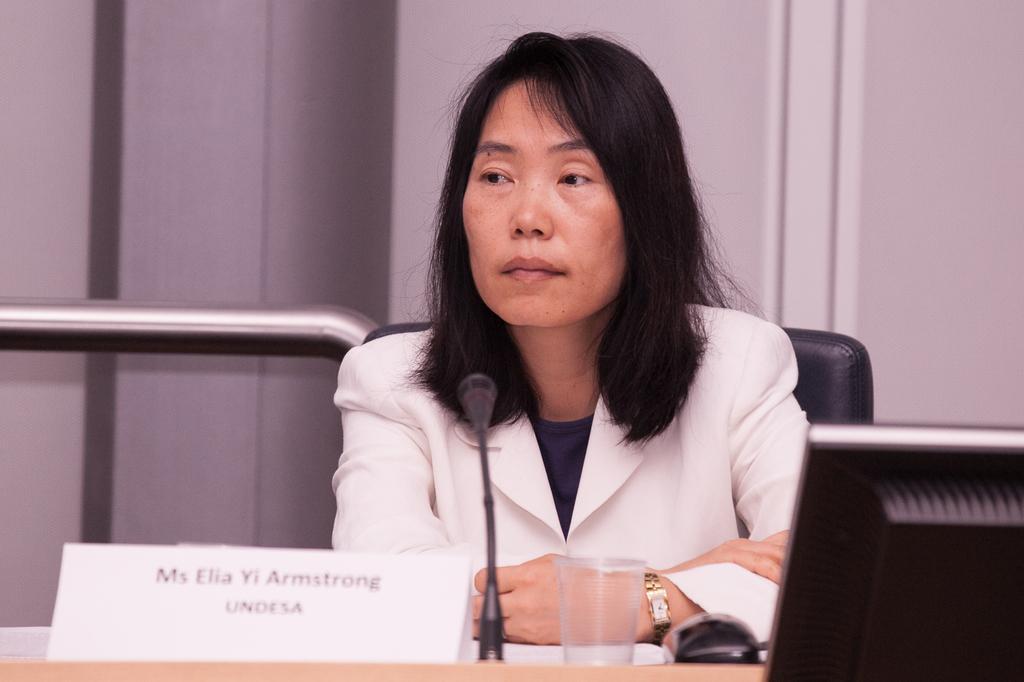Could you give a brief overview of what you see in this image? In this image we can see a lady wearing watch. In front of her there is a mic, name board, glass, mouse and a monitor. In the back there is a wall. And she is sitting on a chair. And there is a steel rod. 